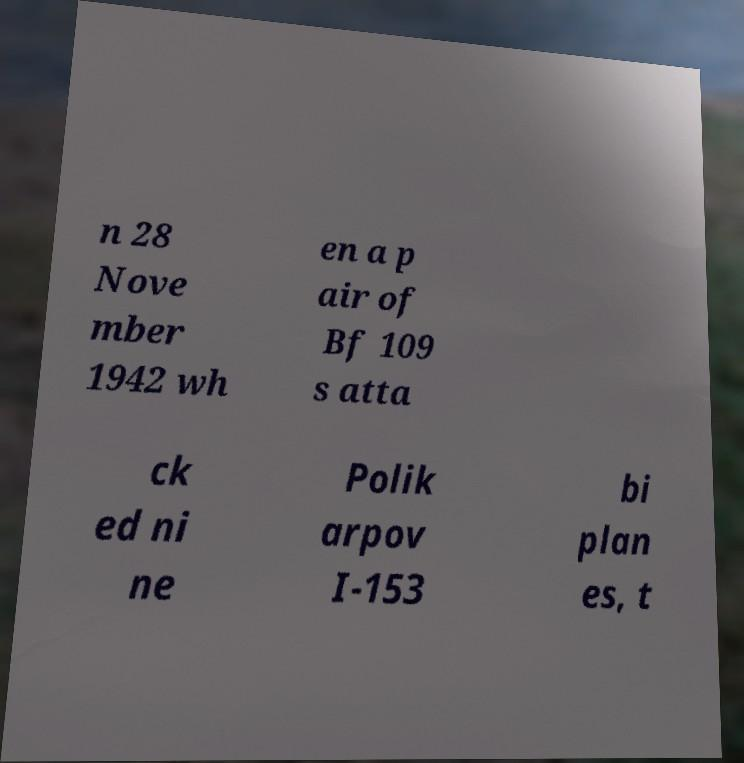Could you extract and type out the text from this image? n 28 Nove mber 1942 wh en a p air of Bf 109 s atta ck ed ni ne Polik arpov I-153 bi plan es, t 